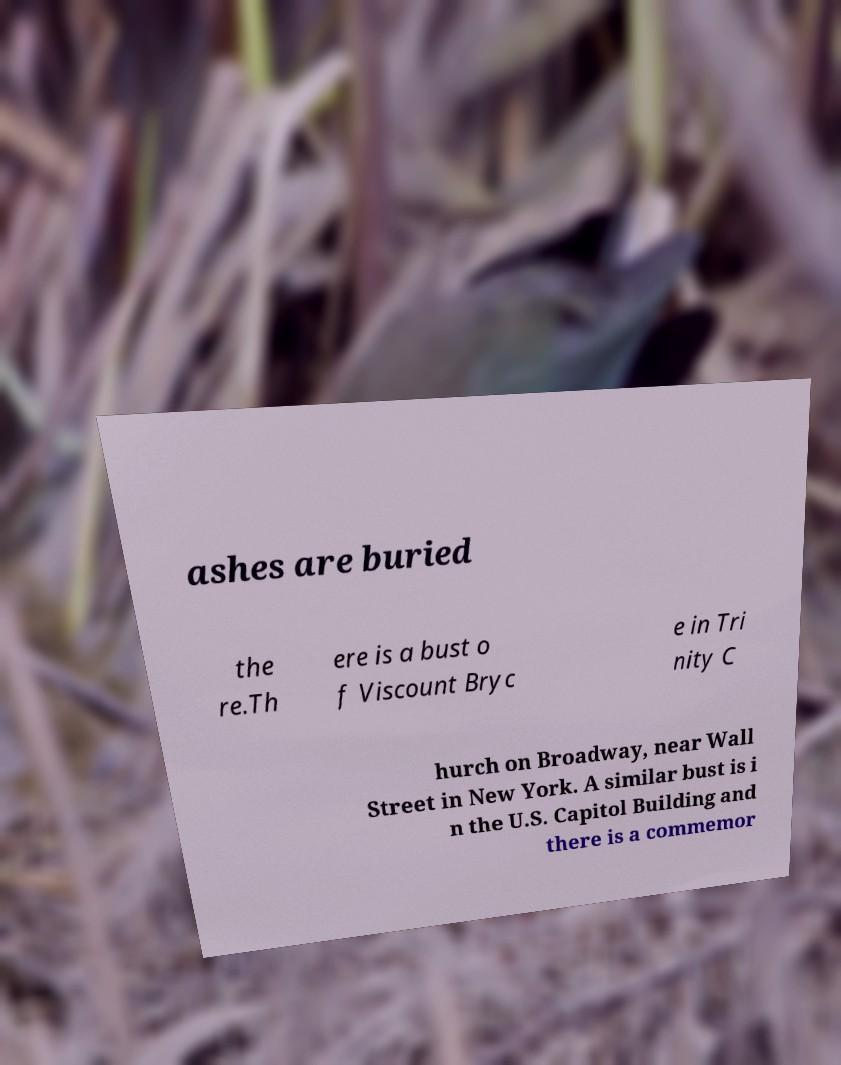Can you accurately transcribe the text from the provided image for me? ashes are buried the re.Th ere is a bust o f Viscount Bryc e in Tri nity C hurch on Broadway, near Wall Street in New York. A similar bust is i n the U.S. Capitol Building and there is a commemor 